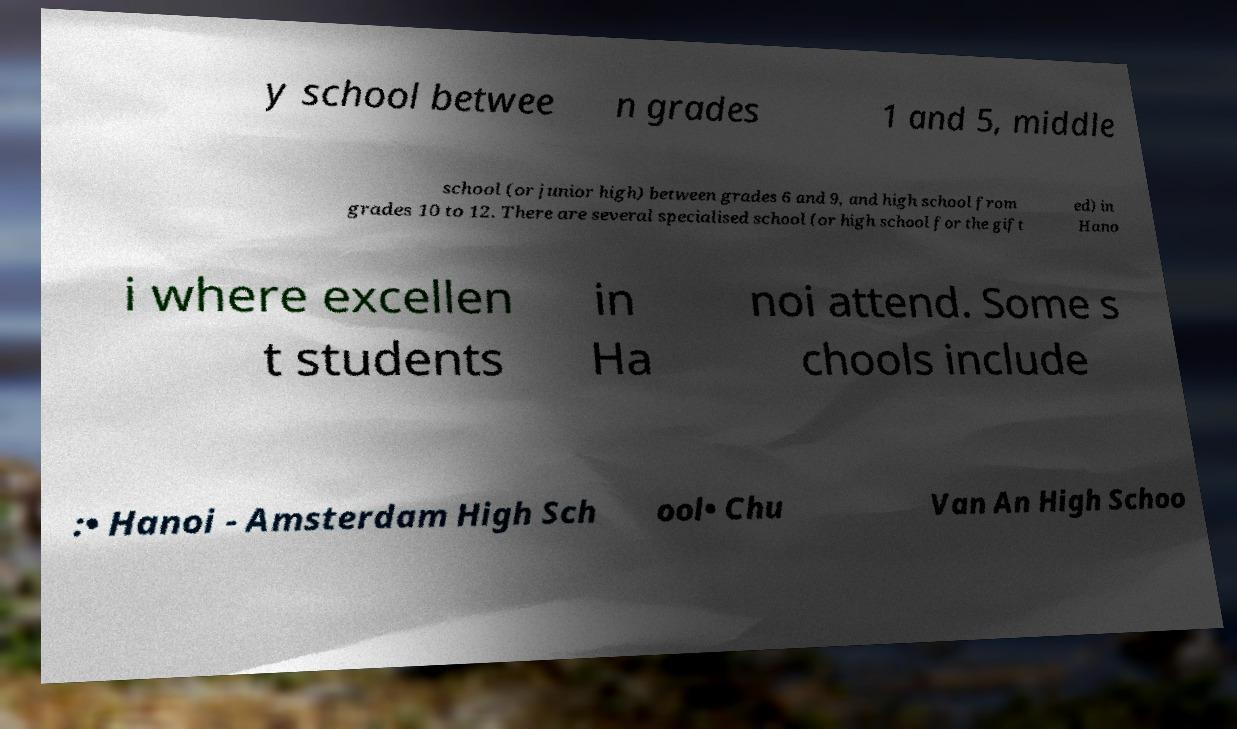I need the written content from this picture converted into text. Can you do that? y school betwee n grades 1 and 5, middle school (or junior high) between grades 6 and 9, and high school from grades 10 to 12. There are several specialised school (or high school for the gift ed) in Hano i where excellen t students in Ha noi attend. Some s chools include :• Hanoi - Amsterdam High Sch ool• Chu Van An High Schoo 